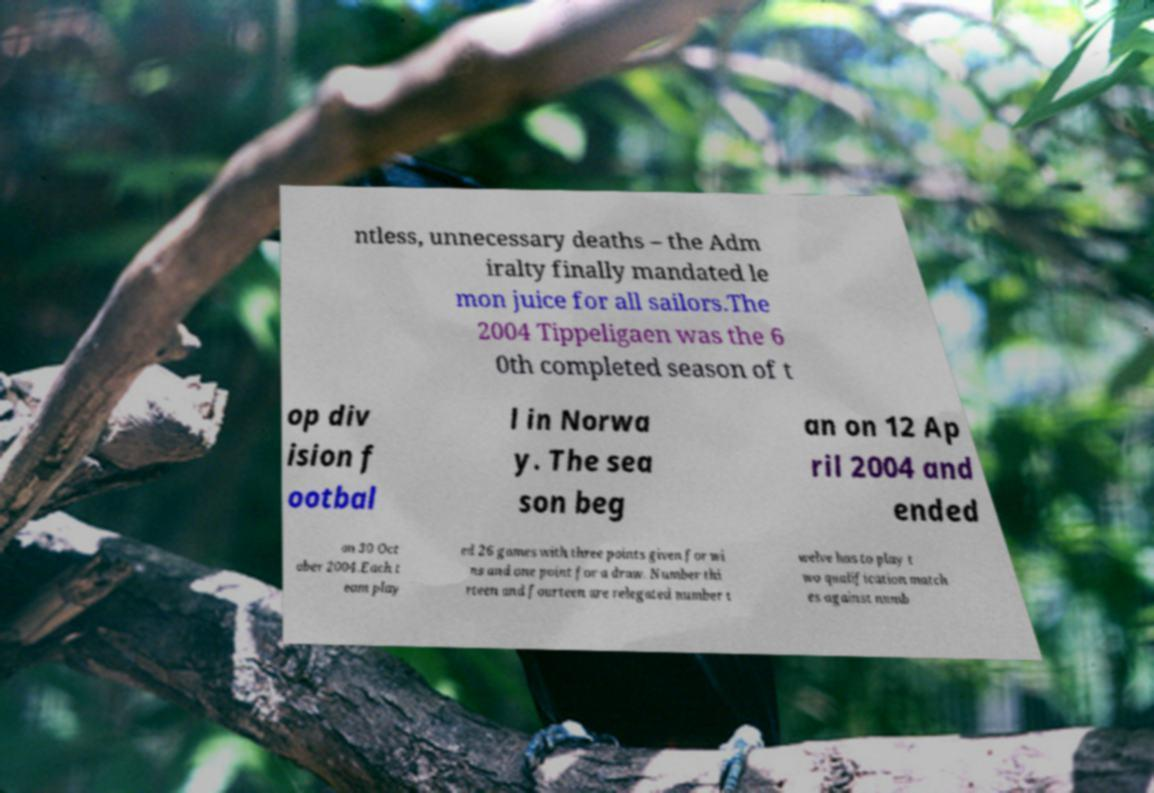Could you extract and type out the text from this image? ntless, unnecessary deaths – the Adm iralty finally mandated le mon juice for all sailors.The 2004 Tippeligaen was the 6 0th completed season of t op div ision f ootbal l in Norwa y. The sea son beg an on 12 Ap ril 2004 and ended on 30 Oct ober 2004.Each t eam play ed 26 games with three points given for wi ns and one point for a draw. Number thi rteen and fourteen are relegated number t welve has to play t wo qualification match es against numb 